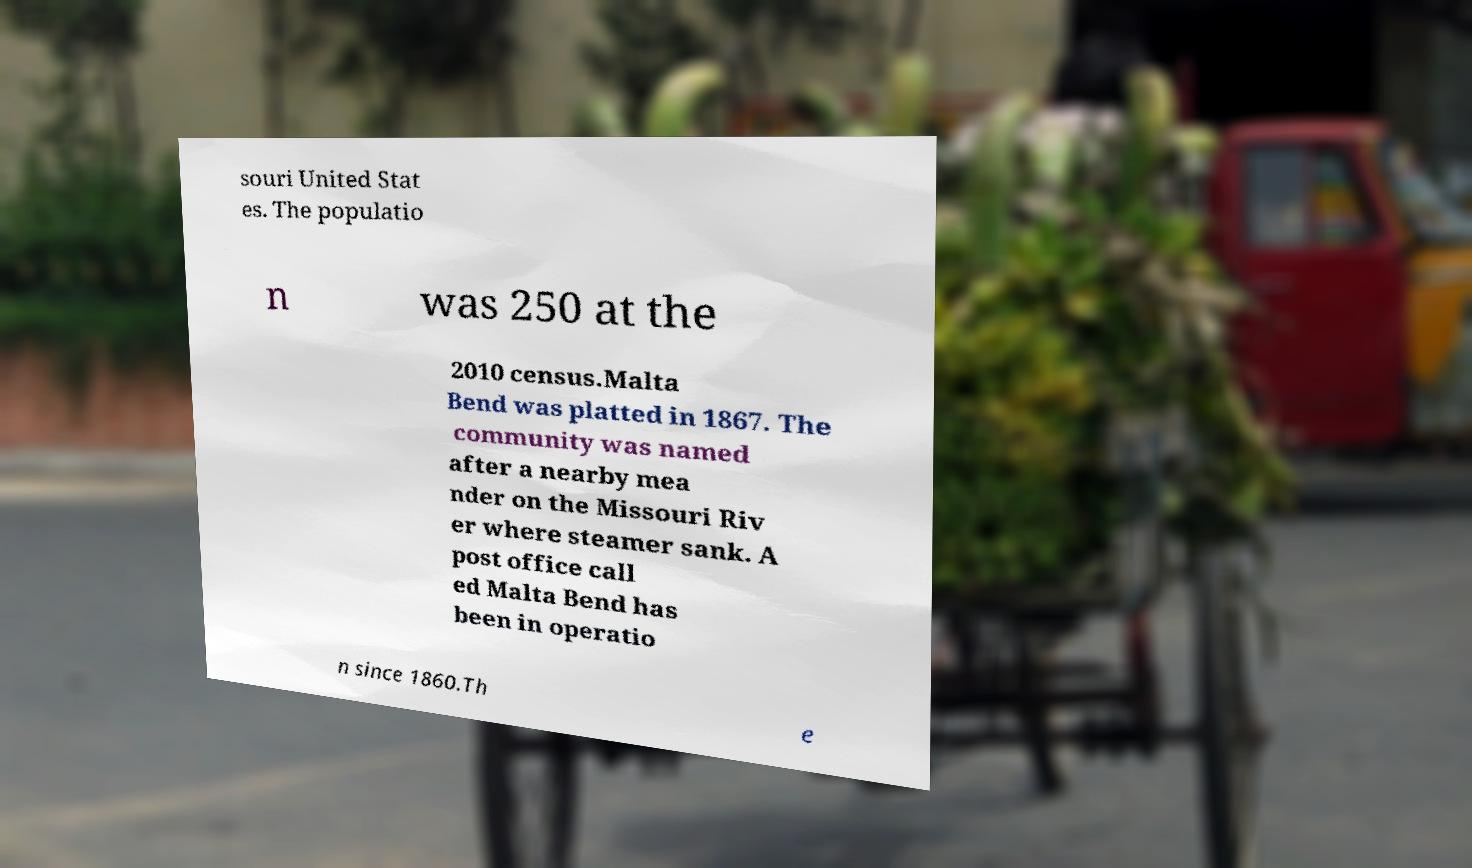Could you extract and type out the text from this image? souri United Stat es. The populatio n was 250 at the 2010 census.Malta Bend was platted in 1867. The community was named after a nearby mea nder on the Missouri Riv er where steamer sank. A post office call ed Malta Bend has been in operatio n since 1860.Th e 